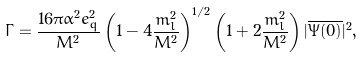<formula> <loc_0><loc_0><loc_500><loc_500>\Gamma = \frac { 1 6 \pi \alpha ^ { 2 } e _ { q } ^ { 2 } } { M ^ { 2 } } \left ( 1 - 4 \frac { m _ { l } ^ { 2 } } { M ^ { 2 } } \right ) ^ { 1 / 2 } \left ( 1 + 2 \frac { m _ { l } ^ { 2 } } { M ^ { 2 } } \right ) | \overline { \Psi ( 0 ) } | ^ { 2 } ,</formula> 